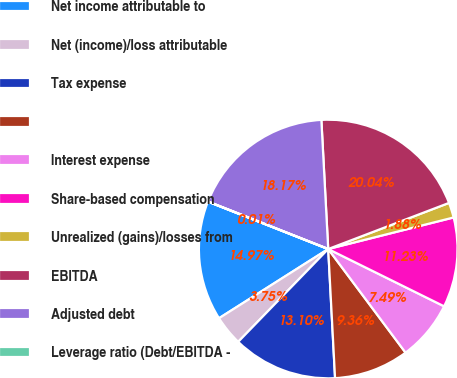Convert chart to OTSL. <chart><loc_0><loc_0><loc_500><loc_500><pie_chart><fcel>Net income attributable to<fcel>Net (income)/loss attributable<fcel>Tax expense<fcel>Unnamed: 3<fcel>Interest expense<fcel>Share-based compensation<fcel>Unrealized (gains)/losses from<fcel>EBITDA<fcel>Adjusted debt<fcel>Leverage ratio (Debt/EBITDA -<nl><fcel>14.97%<fcel>3.75%<fcel>13.1%<fcel>9.36%<fcel>7.49%<fcel>11.23%<fcel>1.88%<fcel>20.04%<fcel>18.17%<fcel>0.01%<nl></chart> 